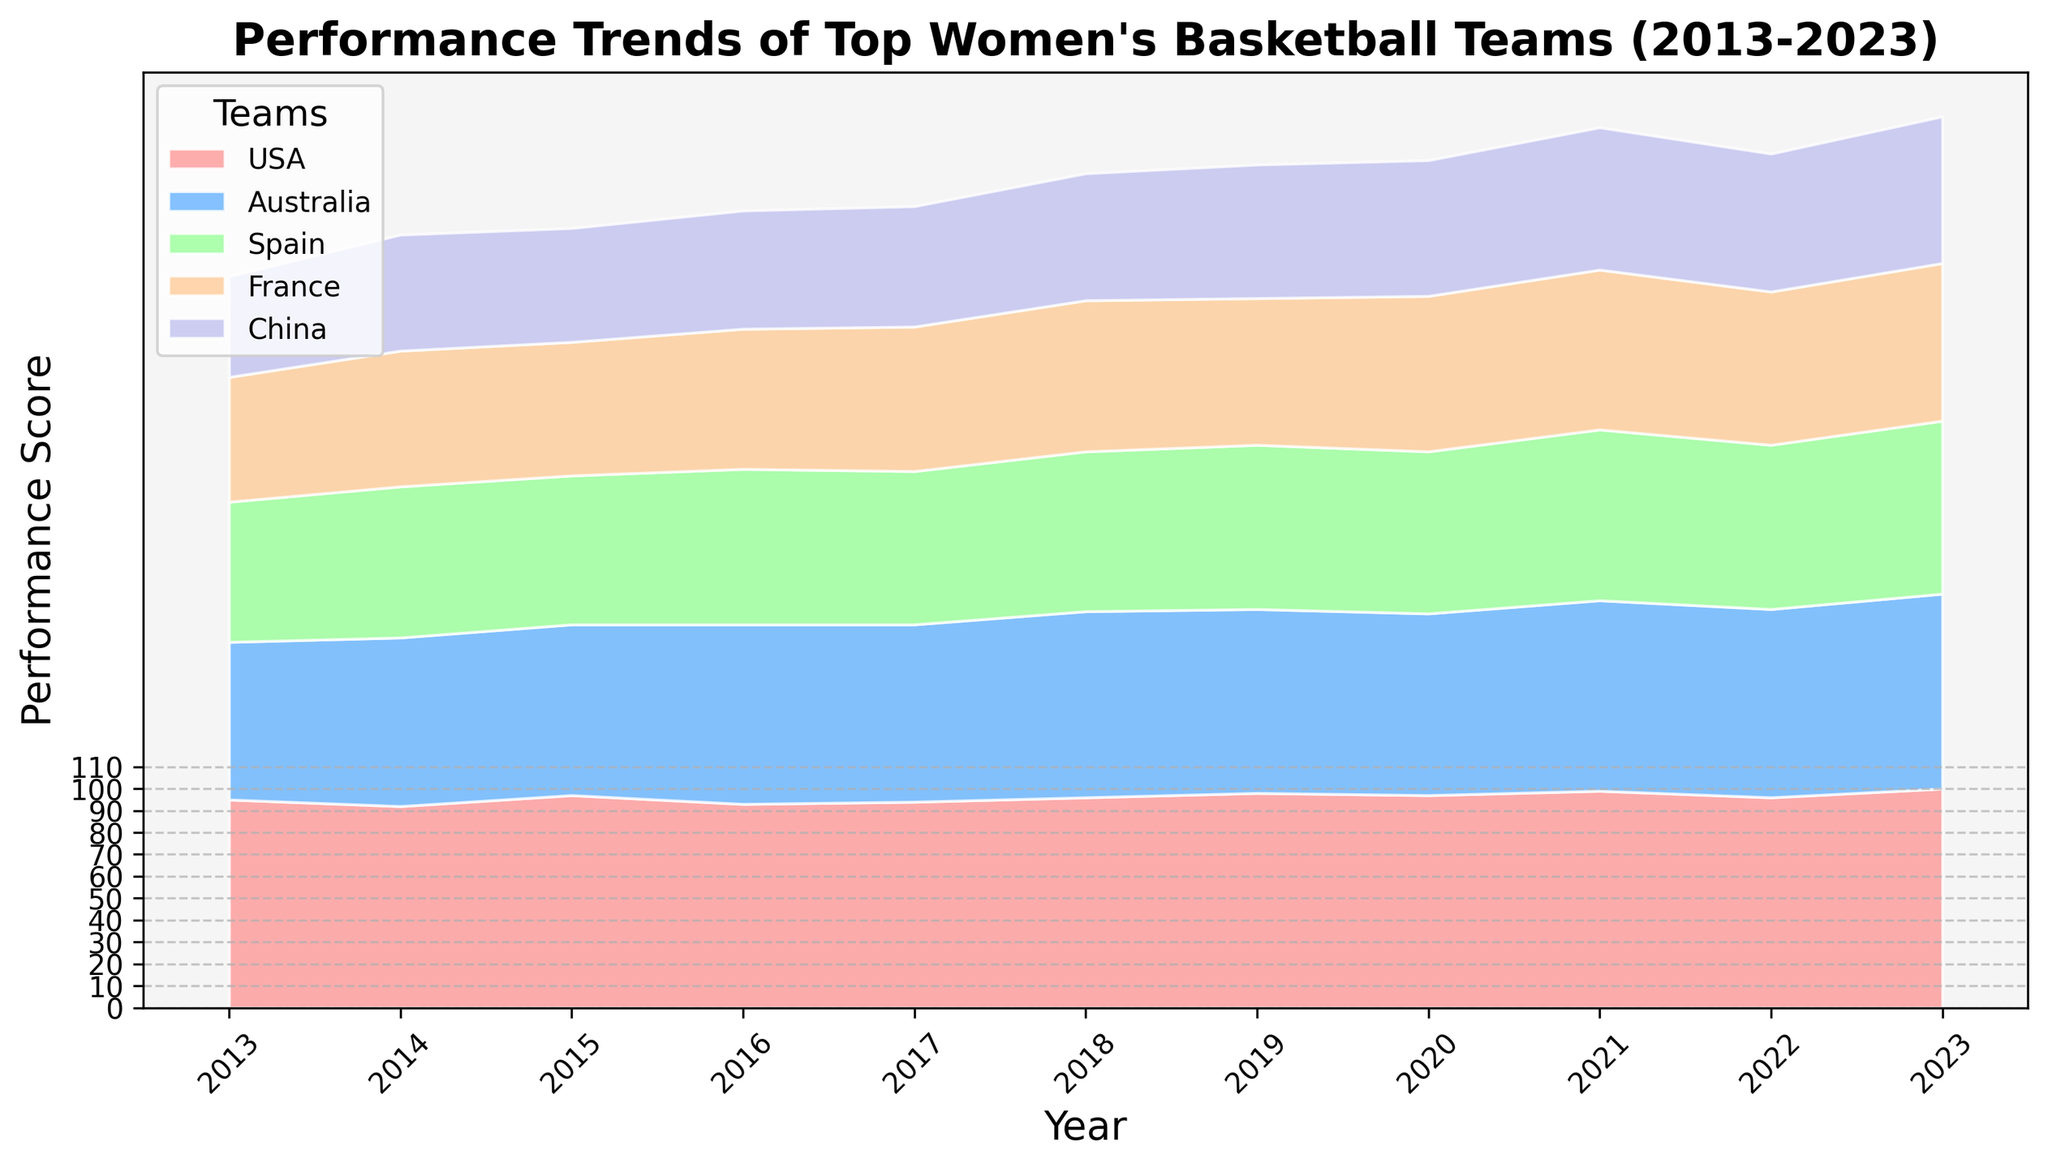What is the trend of the USA team's performance over the past decade? The USA team's performance score appears to consistently increase over the years. Starting from 95 in 2013 and reaching 100 in 2023.
Answer: Increasing Which team showed the highest performance score in 2016? Observing the height of the stacked areas in 2016, the USA team has the highest performance score.
Answer: USA Compare the performance of Australia and France in 2019. Which team performed better? In 2019, Australia's performance score is 84, whereas France's score is 67. Therefore, Australia performed better than France in 2019.
Answer: Australia How did the performance of Spain change from 2013 to 2023? In 2013, Spain's performance score was 64. By 2023, it increased to 79. Therefore, Spain's performance improved over the decade.
Answer: Improved What is the difference in performance scores between China and France in 2023? In 2023, the performance score of China is 67 and France is 72. The difference is 72 - 67 = 5.
Answer: 5 Which team had the largest increase in their performance score from 2013 to 2023? By calculating the difference for each team from 2013 to 2023: USA (100-95=5), Australia (89-72=17), Spain (79-64=15), France (72-57=15), China (67-46=21). Therefore, China had the largest increase.
Answer: China Between which years did Australia's performance see the most significant jump? Comparing the year-to-year changes for Australia: 2013-2014 (5), 2014-2015 (1), 2015-2016 (4), 2016-2017 (-1), 2017-2018 (4), 2018-2019 (-1), 2019-2020 (-1), 2020-2021 (4), 2021-2022 (-1), 2022-2023 (3). The biggest jump is from 2013 to 2014.
Answer: 2013-2014 In which year did France have its highest performance score over the decade? Observing France's performance score over the years, its highest score is 73 in 2021.
Answer: 2021 What is the average performance score of China from 2013 to 2023? Adding all the values for China (46+53+52+54+55+58+61+62+65+63+67 = 636) and dividing by 11 gives approximately 57.82.
Answer: 57.82 